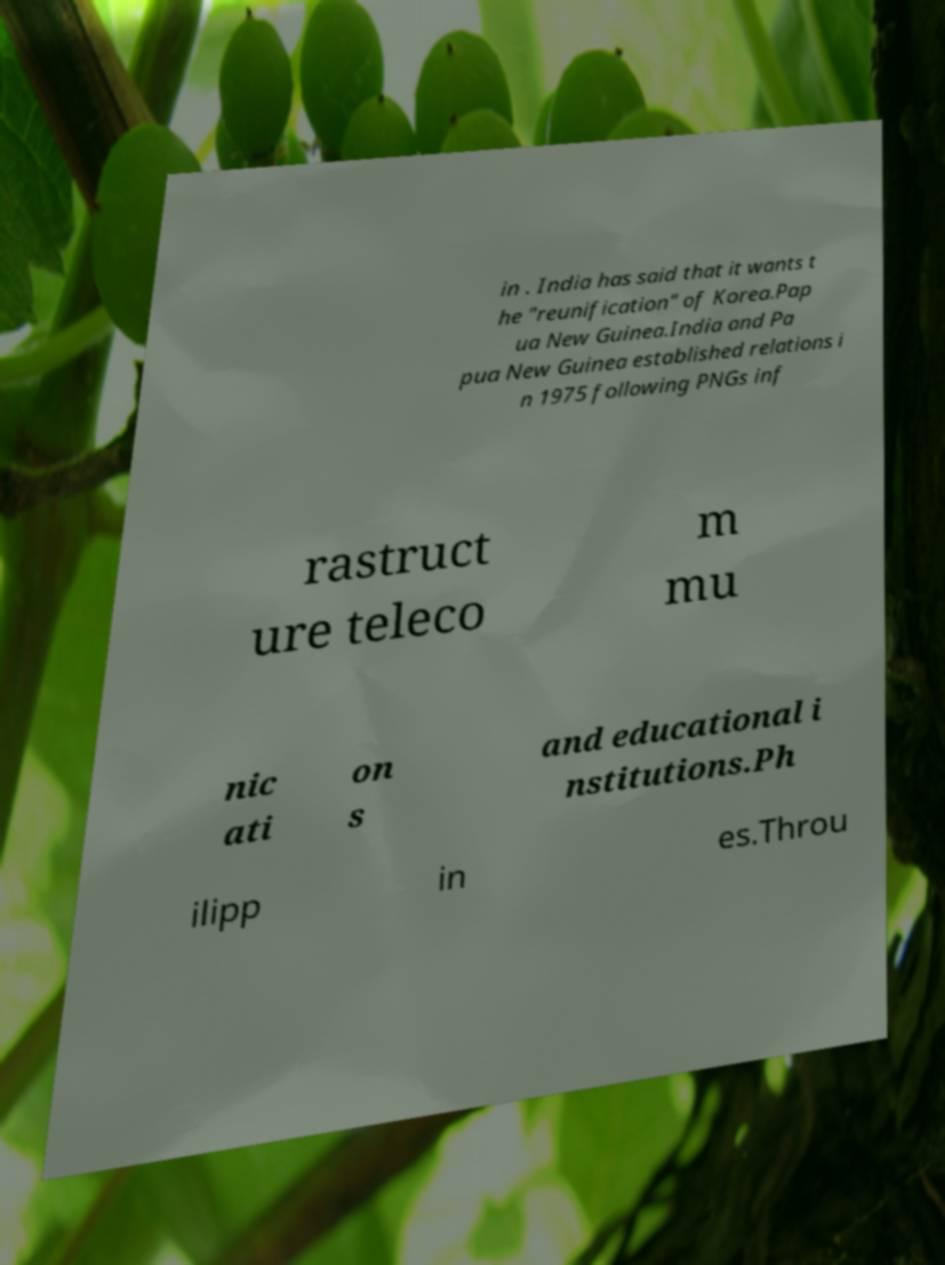Can you accurately transcribe the text from the provided image for me? in . India has said that it wants t he "reunification" of Korea.Pap ua New Guinea.India and Pa pua New Guinea established relations i n 1975 following PNGs inf rastruct ure teleco m mu nic ati on s and educational i nstitutions.Ph ilipp in es.Throu 